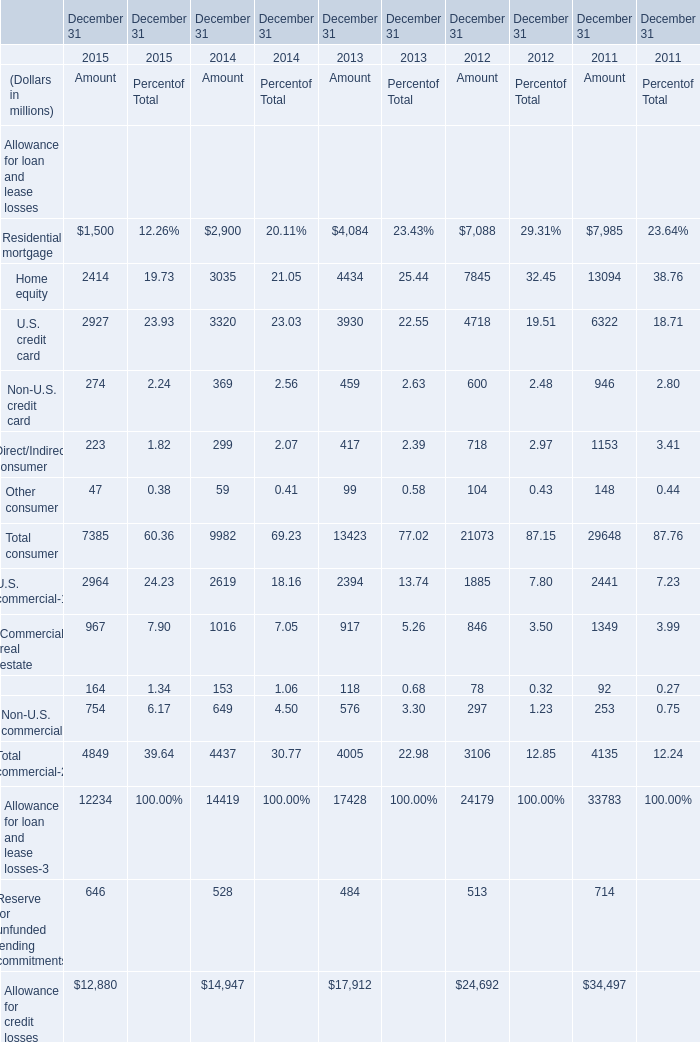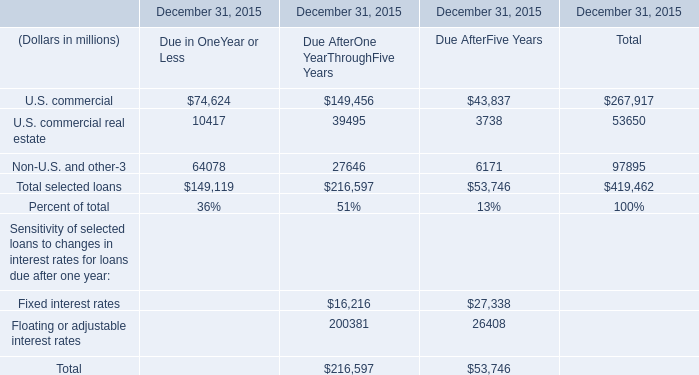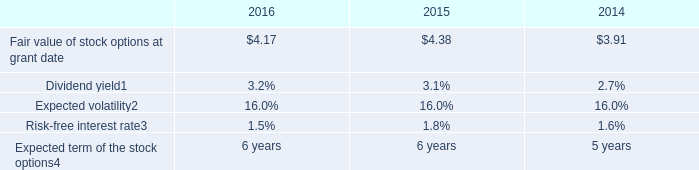What's the total amount of the U.S. credit card in the years where Home equity is greater than 10000? (in million) 
Answer: 6322. 